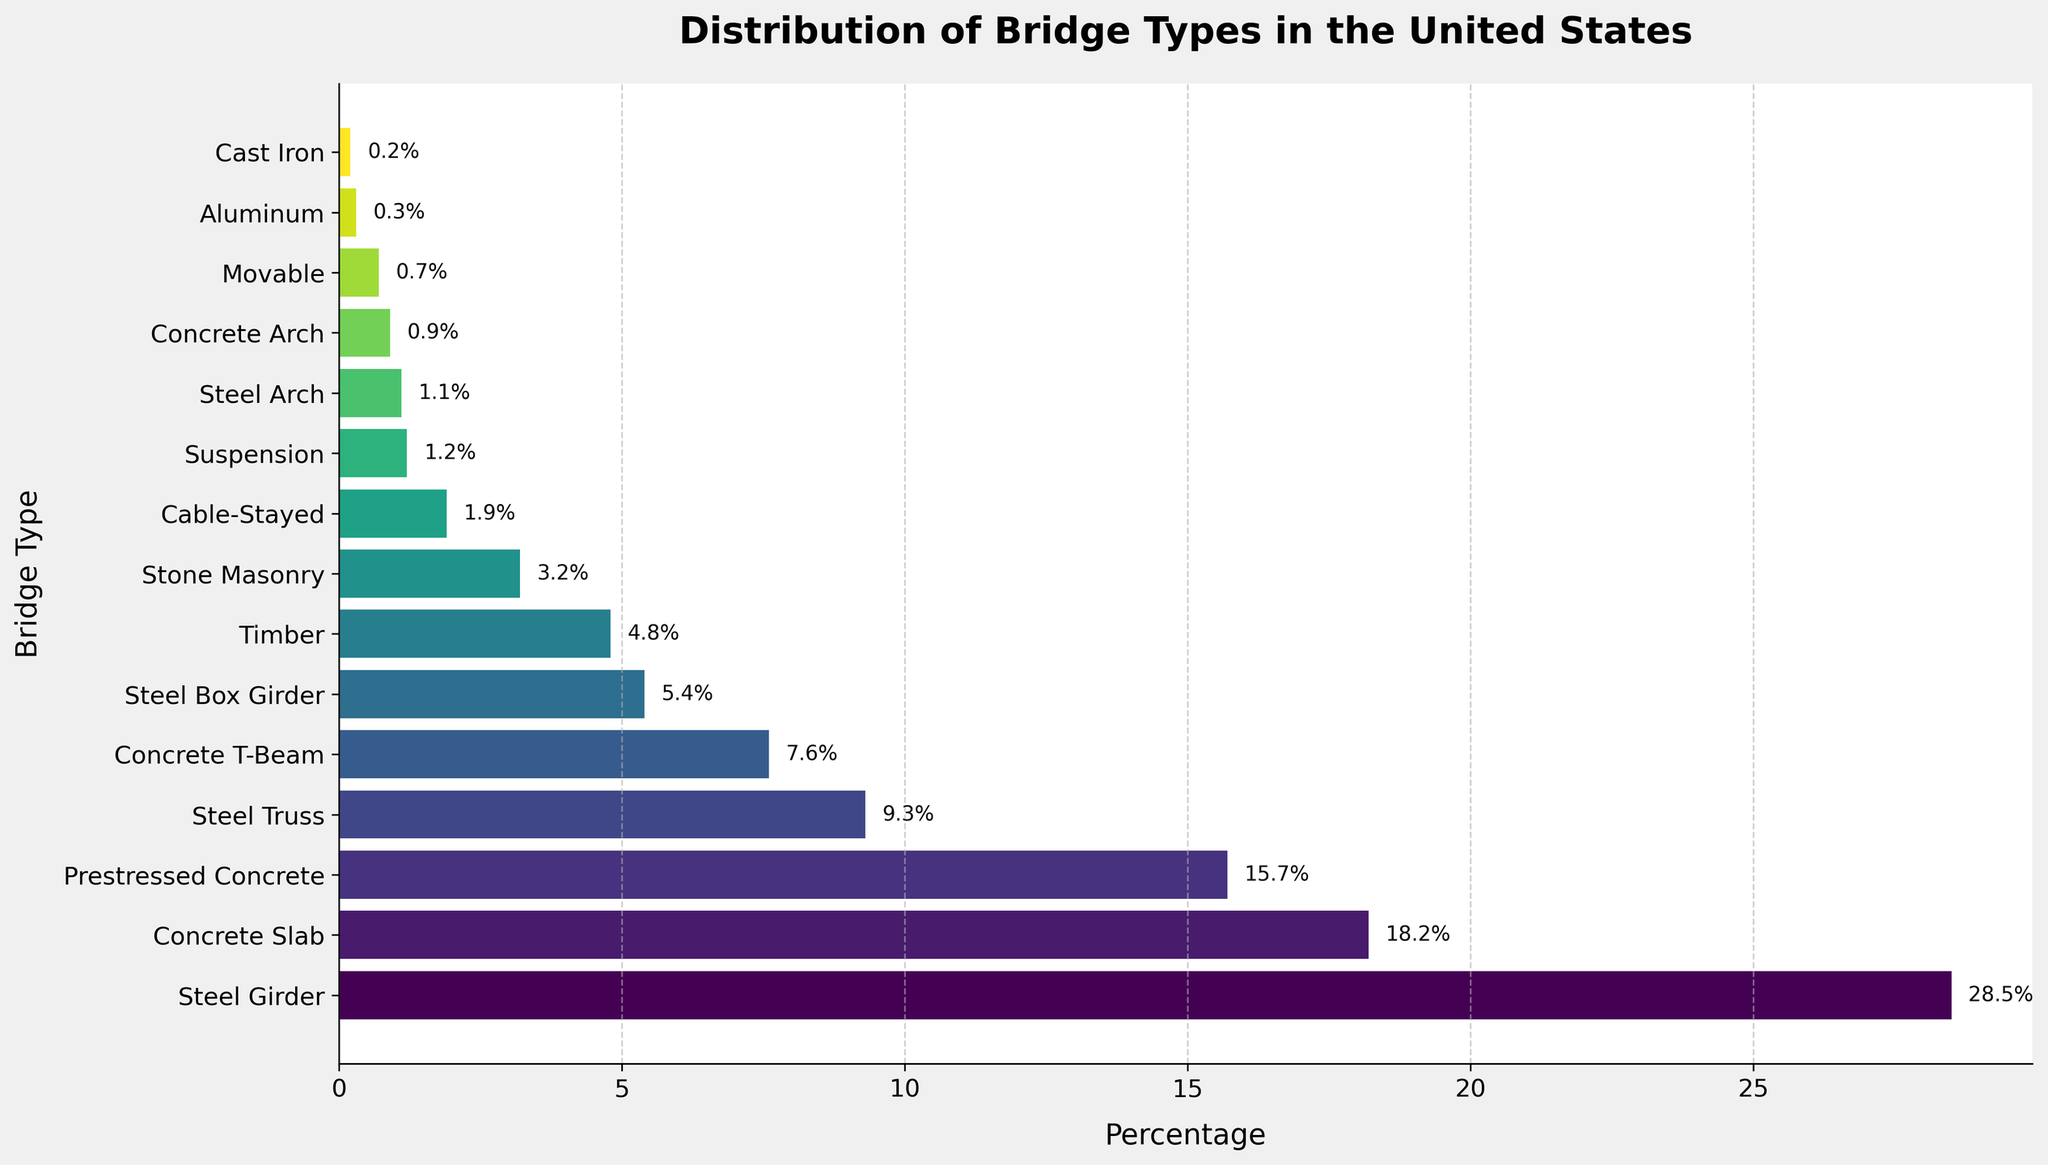Which bridge type has the highest percentage? The bar labeled "Steel Girder" is the longest, and the percentage label shows 28.5%, which is the highest among all the bars.
Answer: Steel Girder What is the combined percentage of Steel Girder and Concrete Slab bridges? The percentages for Steel Girder and Concrete Slab are 28.5% and 18.2% respectively. Adding them together gives 28.5 + 18.2 = 46.7%.
Answer: 46.7% How many bridge types have a percentage greater than 10%? By inspecting the lengths of the bars and their associated percentages, the bridges with percentages greater than 10% are Steel Girder, Concrete Slab, and Prestressed Concrete. There are three such types.
Answer: 3 Which bridge type has a higher percentage: Timber or Cable-Stayed? Comparing the lengths of the bars for Timber and Cable-Stayed, the percentage label for Timber is 4.8%, and for Cable-Stayed, it is 1.9%. Timber has a higher percentage.
Answer: Timber What is the difference in percentage between Steel Girder and Steel Truss bridges? The percentages for Steel Girder and Steel Truss are 28.5% and 9.3% respectively. Subtracting these gives 28.5 - 9.3 = 19.2%.
Answer: 19.2% What is the average percentage of the top four bridge types? The top four bridge types are Steel Girder, Concrete Slab, Prestressed Concrete, and Steel Truss with percentages 28.5%, 18.2%, 15.7%, and 9.3% respectively. Adding these gives 28.5 + 18.2 + 15.7 + 9.3 = 71.7. Dividing by 4 gives 71.7 / 4 = 17.925%.
Answer: 17.925% What bridge types have a percentage between 1% and 5%? The bars with associated percentages between 1% and 5% are Timber (4.8%), Stone Masonry (3.2%), Cable-Stayed (1.9%), and Suspension (1.2%).
Answer: Timber, Stone Masonry, Cable-Stayed, Suspension What is the percentage difference between the least common (Cast Iron) and the most common (Steel Girder) bridge types? The percentages for Cast Iron and Steel Girder are 0.2% and 28.5% respectively. Subtracting these gives 28.5 - 0.2 = 28.3%.
Answer: 28.3% Which has more bridge types: materials composed primarily of concrete or primarily of steel? The concrete types include Concrete Slab, Prestressed Concrete, Concrete T-Beam, and Concrete Arch (4 types). The steel types include Steel Girder, Steel Truss, Steel Box Girder, and Steel Arch (4 types).
Answer: Equal (4 each) What is the median percentage value of all bridge types? Listing the percentages in order: 0.2, 0.3, 0.7, 0.9, 1.1, 1.2, 1.9, 3.2, 4.8, 5.4, 7.6, 9.3, 15.7, 18.2, 28.5. The middle value (8th value in the ordered list of 15 values) is 4.8%.
Answer: 4.8% 